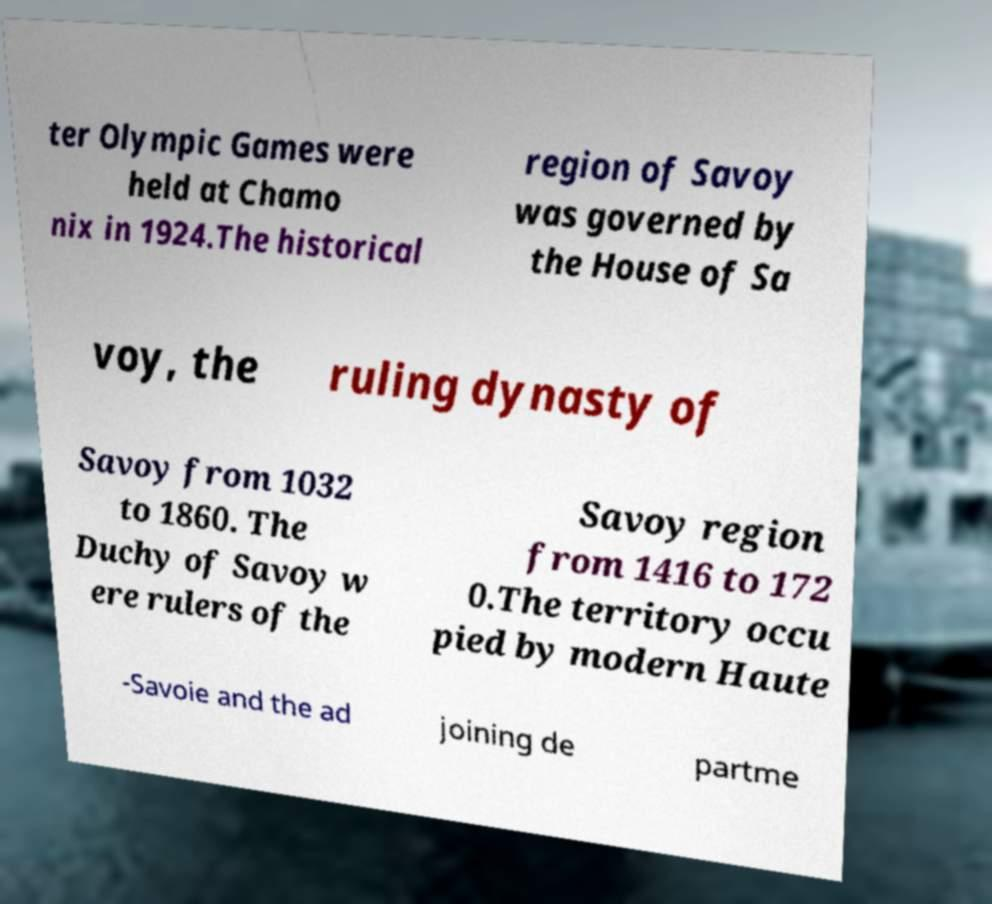Can you accurately transcribe the text from the provided image for me? ter Olympic Games were held at Chamo nix in 1924.The historical region of Savoy was governed by the House of Sa voy, the ruling dynasty of Savoy from 1032 to 1860. The Duchy of Savoy w ere rulers of the Savoy region from 1416 to 172 0.The territory occu pied by modern Haute -Savoie and the ad joining de partme 